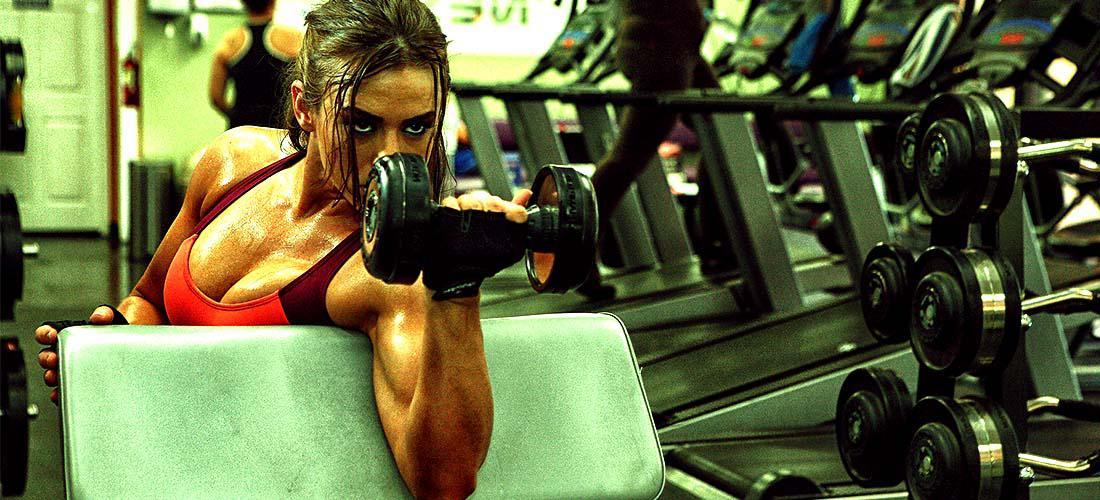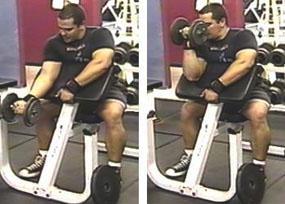The first image is the image on the left, the second image is the image on the right. Analyze the images presented: Is the assertion "there is a male with a dumbbell near his face" valid? Answer yes or no. Yes. 